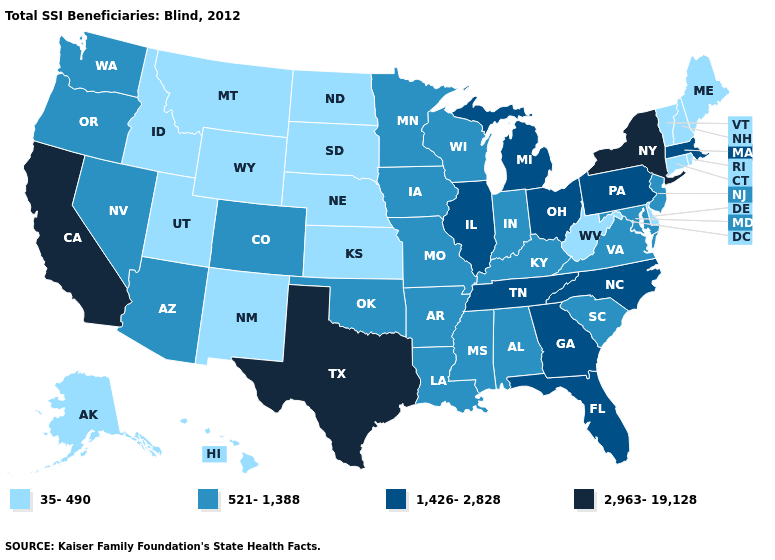What is the value of Iowa?
Answer briefly. 521-1,388. Which states have the lowest value in the MidWest?
Be succinct. Kansas, Nebraska, North Dakota, South Dakota. Among the states that border Wyoming , which have the lowest value?
Concise answer only. Idaho, Montana, Nebraska, South Dakota, Utah. Name the states that have a value in the range 521-1,388?
Concise answer only. Alabama, Arizona, Arkansas, Colorado, Indiana, Iowa, Kentucky, Louisiana, Maryland, Minnesota, Mississippi, Missouri, Nevada, New Jersey, Oklahoma, Oregon, South Carolina, Virginia, Washington, Wisconsin. Among the states that border New York , which have the lowest value?
Give a very brief answer. Connecticut, Vermont. Name the states that have a value in the range 1,426-2,828?
Quick response, please. Florida, Georgia, Illinois, Massachusetts, Michigan, North Carolina, Ohio, Pennsylvania, Tennessee. Does the map have missing data?
Short answer required. No. Does Rhode Island have the same value as Vermont?
Concise answer only. Yes. Which states have the highest value in the USA?
Quick response, please. California, New York, Texas. Does Texas have the lowest value in the South?
Keep it brief. No. Does North Carolina have the lowest value in the South?
Be succinct. No. Which states hav the highest value in the MidWest?
Concise answer only. Illinois, Michigan, Ohio. Does Tennessee have a lower value than Nevada?
Give a very brief answer. No. What is the value of South Dakota?
Write a very short answer. 35-490. What is the value of Georgia?
Concise answer only. 1,426-2,828. 